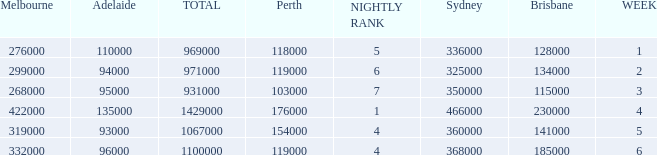What was the rating in Brisbane the week it was 276000 in Melbourne?  128000.0. 